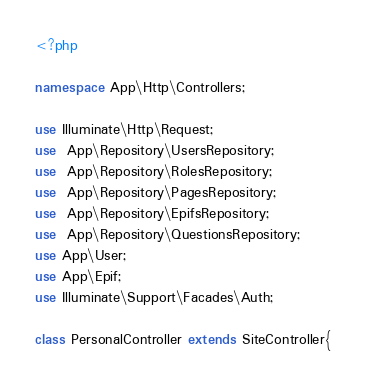<code> <loc_0><loc_0><loc_500><loc_500><_PHP_><?php

namespace App\Http\Controllers;

use Illuminate\Http\Request;
use  App\Repository\UsersRepository;
use  App\Repository\RolesRepository;
use  App\Repository\PagesRepository;
use  App\Repository\EpifsRepository;
use  App\Repository\QuestionsRepository;
use App\User;
use App\Epif;
use Illuminate\Support\Facades\Auth;

class PersonalController extends SiteController{

</code> 